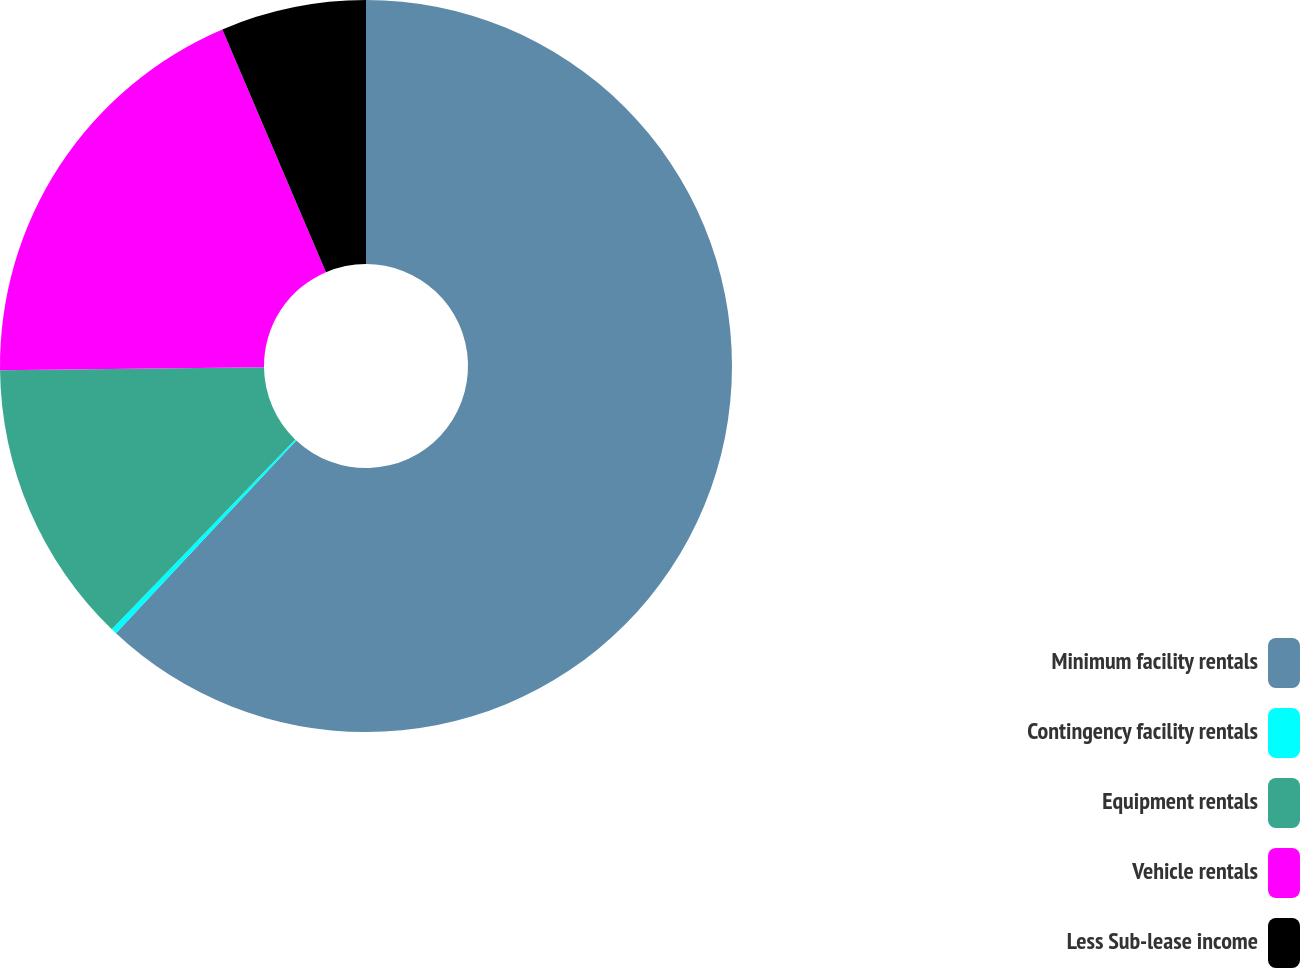Convert chart. <chart><loc_0><loc_0><loc_500><loc_500><pie_chart><fcel>Minimum facility rentals<fcel>Contingency facility rentals<fcel>Equipment rentals<fcel>Vehicle rentals<fcel>Less Sub-lease income<nl><fcel>61.97%<fcel>0.25%<fcel>12.59%<fcel>18.77%<fcel>6.42%<nl></chart> 